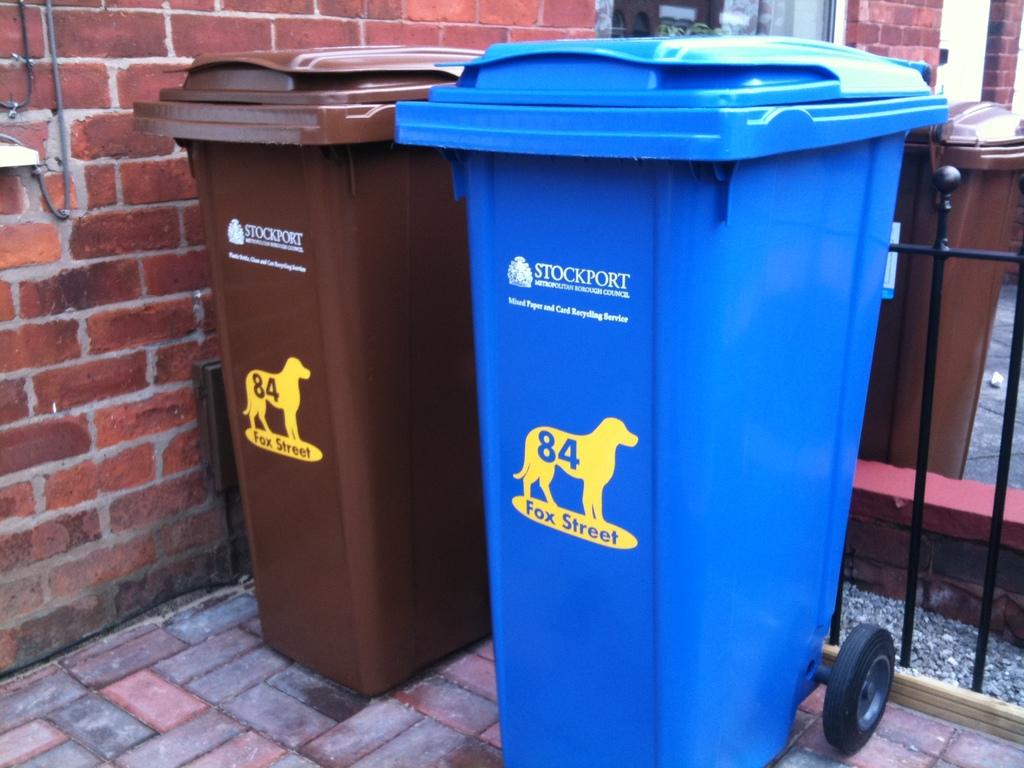What number is the long hand pointing to?
Your answer should be compact. Unanswerable. 